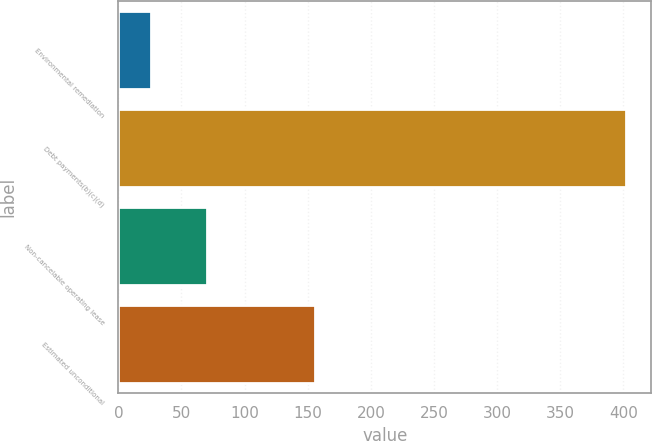Convert chart to OTSL. <chart><loc_0><loc_0><loc_500><loc_500><bar_chart><fcel>Environmental remediation<fcel>Debt payments(b)(c)(d)<fcel>Non-cancelable operating lease<fcel>Estimated unconditional<nl><fcel>26<fcel>402<fcel>70<fcel>156<nl></chart> 